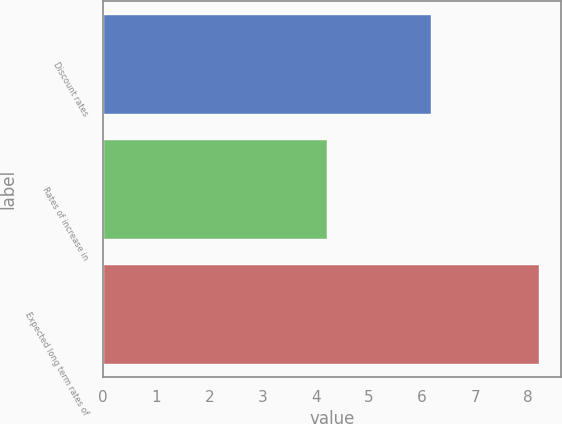<chart> <loc_0><loc_0><loc_500><loc_500><bar_chart><fcel>Discount rates<fcel>Rates of increase in<fcel>Expected long term rates of<nl><fcel>6.17<fcel>4.22<fcel>8.2<nl></chart> 